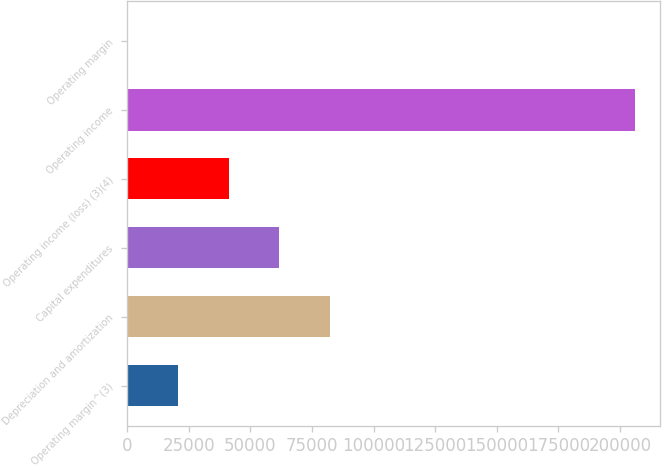Convert chart to OTSL. <chart><loc_0><loc_0><loc_500><loc_500><bar_chart><fcel>Operating margin^(3)<fcel>Depreciation and amortization<fcel>Capital expenditures<fcel>Operating income (loss) (3)(4)<fcel>Operating income<fcel>Operating margin<nl><fcel>20608<fcel>82390.7<fcel>61796.5<fcel>41202.2<fcel>205956<fcel>13.8<nl></chart> 